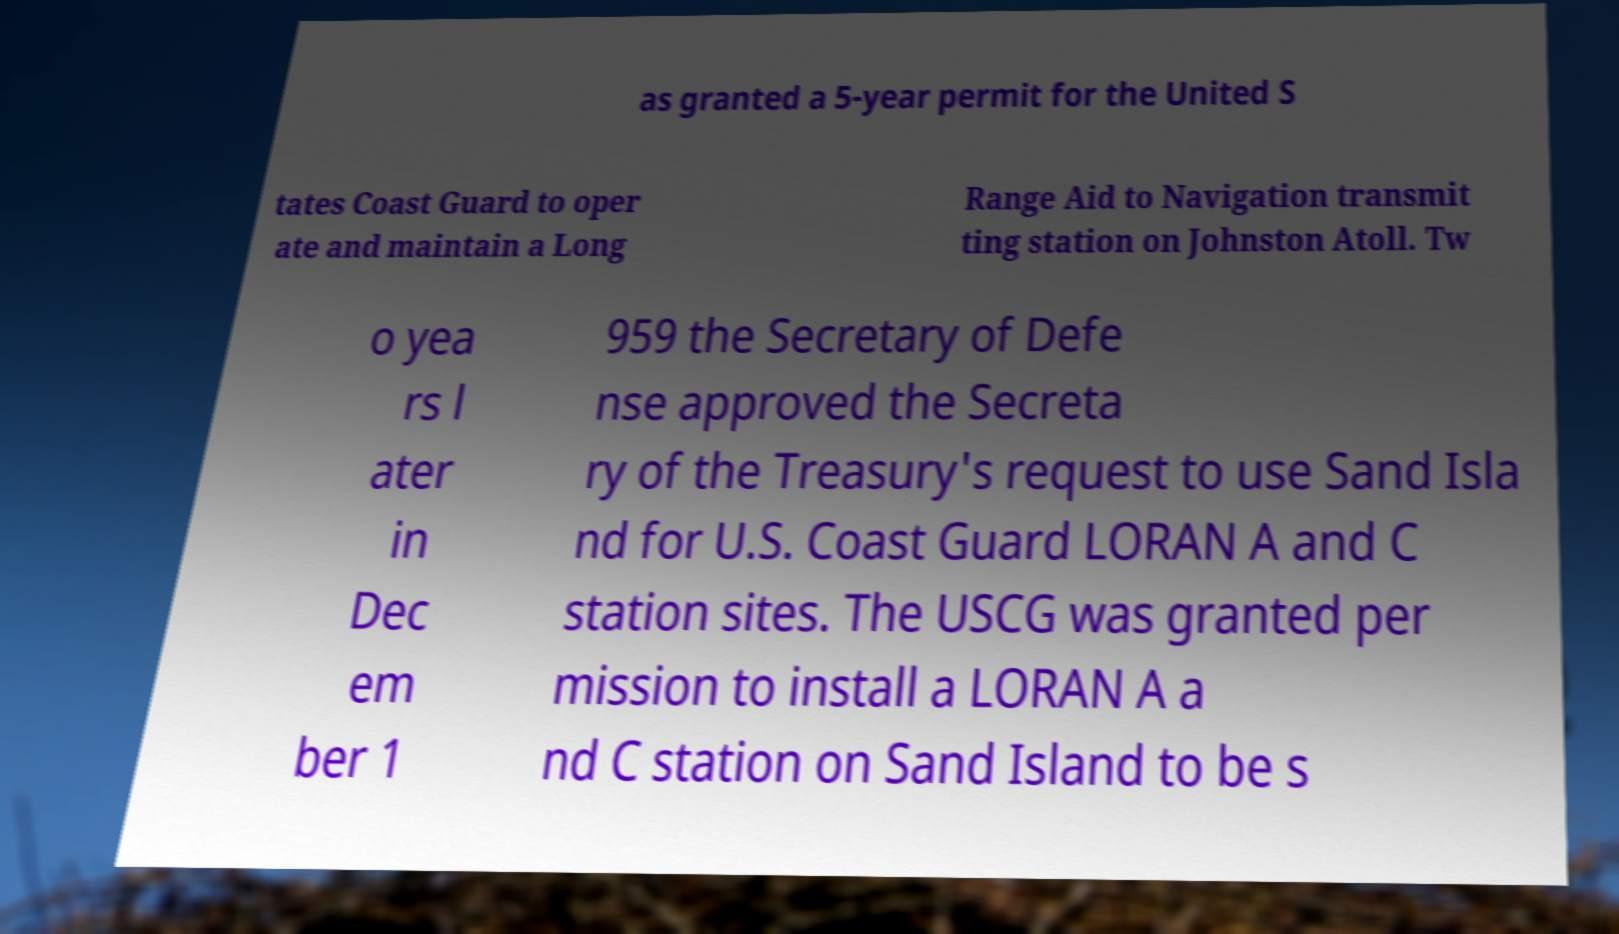Could you assist in decoding the text presented in this image and type it out clearly? as granted a 5-year permit for the United S tates Coast Guard to oper ate and maintain a Long Range Aid to Navigation transmit ting station on Johnston Atoll. Tw o yea rs l ater in Dec em ber 1 959 the Secretary of Defe nse approved the Secreta ry of the Treasury's request to use Sand Isla nd for U.S. Coast Guard LORAN A and C station sites. The USCG was granted per mission to install a LORAN A a nd C station on Sand Island to be s 